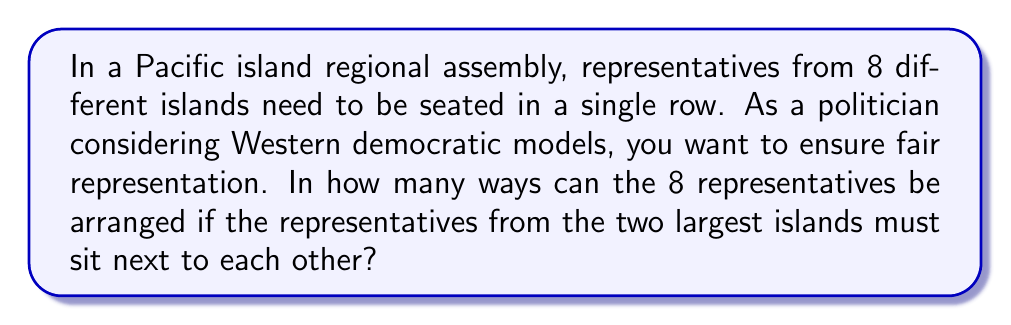Teach me how to tackle this problem. Let's approach this step-by-step:

1) First, consider the representatives from the two largest islands as a single unit. This reduces our problem to arranging 7 units (the pair from the largest islands and 6 other representatives).

2) We can arrange these 7 units in $7!$ ways.

3) However, the two representatives within the pair can also be arranged in $2!$ ways.

4) By the multiplication principle, the total number of arrangements is:

   $$ 7! \times 2! $$

5) Let's calculate this:
   $$ 7! \times 2! = (7 \times 6 \times 5 \times 4 \times 3 \times 2 \times 1) \times (2 \times 1) $$
   $$ = 5040 \times 2 = 10080 $$

Therefore, there are 10,080 ways to arrange the representatives with the given condition.
Answer: $10080$ 